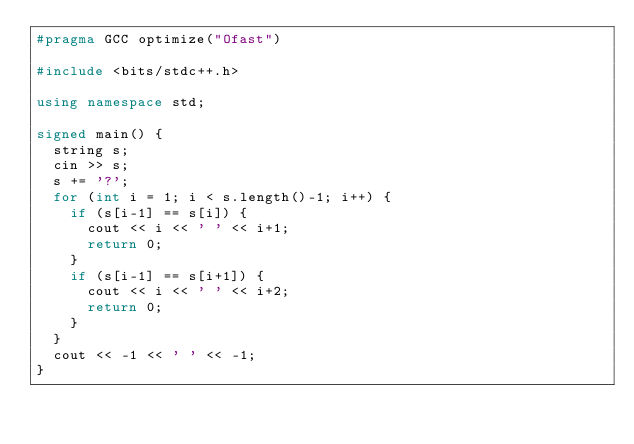Convert code to text. <code><loc_0><loc_0><loc_500><loc_500><_C++_>#pragma GCC optimize("Ofast")

#include <bits/stdc++.h>

using namespace std;

signed main() {
  string s;
  cin >> s;
  s += '?';
  for (int i = 1; i < s.length()-1; i++) {
    if (s[i-1] == s[i]) {
      cout << i << ' ' << i+1;
      return 0;
    }
    if (s[i-1] == s[i+1]) {
      cout << i << ' ' << i+2;
      return 0;
    }
  }
  cout << -1 << ' ' << -1;
}
</code> 